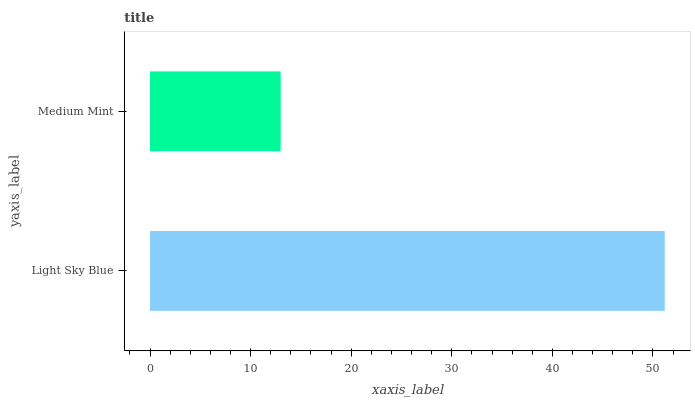Is Medium Mint the minimum?
Answer yes or no. Yes. Is Light Sky Blue the maximum?
Answer yes or no. Yes. Is Medium Mint the maximum?
Answer yes or no. No. Is Light Sky Blue greater than Medium Mint?
Answer yes or no. Yes. Is Medium Mint less than Light Sky Blue?
Answer yes or no. Yes. Is Medium Mint greater than Light Sky Blue?
Answer yes or no. No. Is Light Sky Blue less than Medium Mint?
Answer yes or no. No. Is Light Sky Blue the high median?
Answer yes or no. Yes. Is Medium Mint the low median?
Answer yes or no. Yes. Is Medium Mint the high median?
Answer yes or no. No. Is Light Sky Blue the low median?
Answer yes or no. No. 